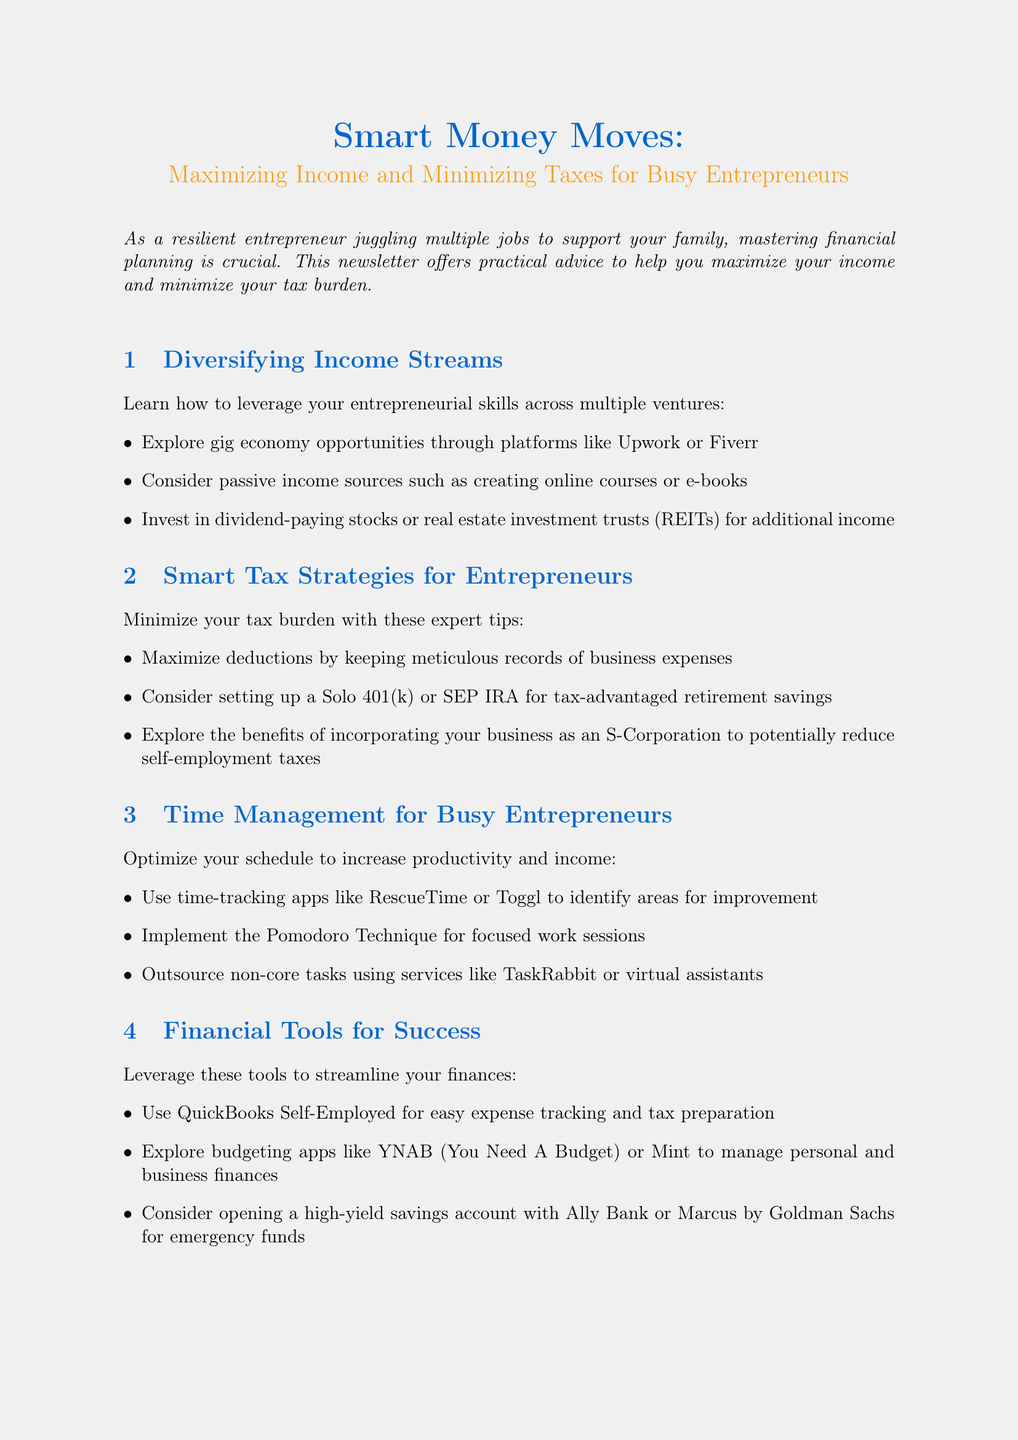What is the title of the newsletter? The title is mentioned at the beginning of the document.
Answer: Smart Money Moves: Maximizing Income and Minimizing Taxes for Busy Entrepreneurs What is a recommended passive income source? Passive income sources are listed under the Diversifying Income Streams section.
Answer: Creating online courses What is the date of the upcoming webinar? The date of the webinar is included in the upcoming event section.
Answer: May 15, 2023 What percentage did Sarah increase her annual income? This percentage is stated in the Success Story case study.
Answer: 35% What is an expert tip related to managing taxes? The expert tip is provided as a box within the newsletter.
Answer: The Power of Estimated Tax Payments What tool is suggested for easy expense tracking? Suggested tools are detailed in the Financial Tools for Success section.
Answer: QuickBooks Self-Employed What is the title of the recommended reading? The title of the book is specified under the Recommended Reading section.
Answer: Profit First: Transform Your Business from a Cash-Eating Monster to a Money-Making Machine What should entrepreneurs consider setting up for tax-advantaged retirement savings? This information is found in the Smart Tax Strategies for Entrepreneurs section.
Answer: A Solo 401(k) or SEP IRA What time is the webinar scheduled for? The time is mentioned in the upcoming event details.
Answer: 7:00 PM EST 